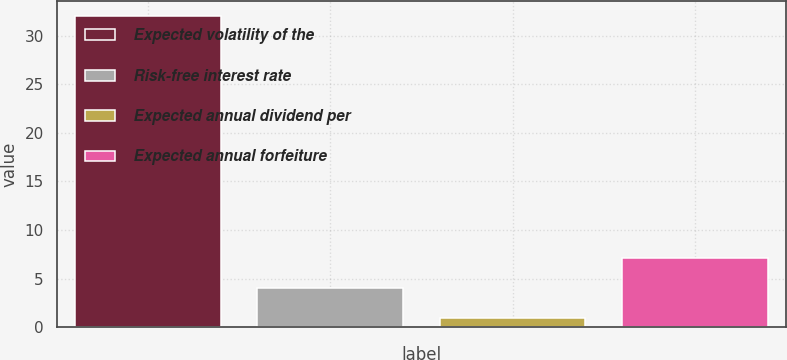<chart> <loc_0><loc_0><loc_500><loc_500><bar_chart><fcel>Expected volatility of the<fcel>Risk-free interest rate<fcel>Expected annual dividend per<fcel>Expected annual forfeiture<nl><fcel>32<fcel>4<fcel>0.89<fcel>7.11<nl></chart> 